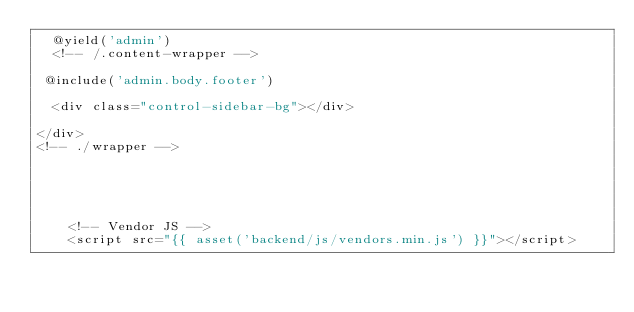Convert code to text. <code><loc_0><loc_0><loc_500><loc_500><_PHP_>  @yield('admin')
  <!-- /.content-wrapper -->

 @include('admin.body.footer')

  <div class="control-sidebar-bg"></div>
  
</div>
<!-- ./wrapper -->
  	



	  
	<!-- Vendor JS -->
	<script src="{{ asset('backend/js/vendors.min.js') }}"></script></code> 